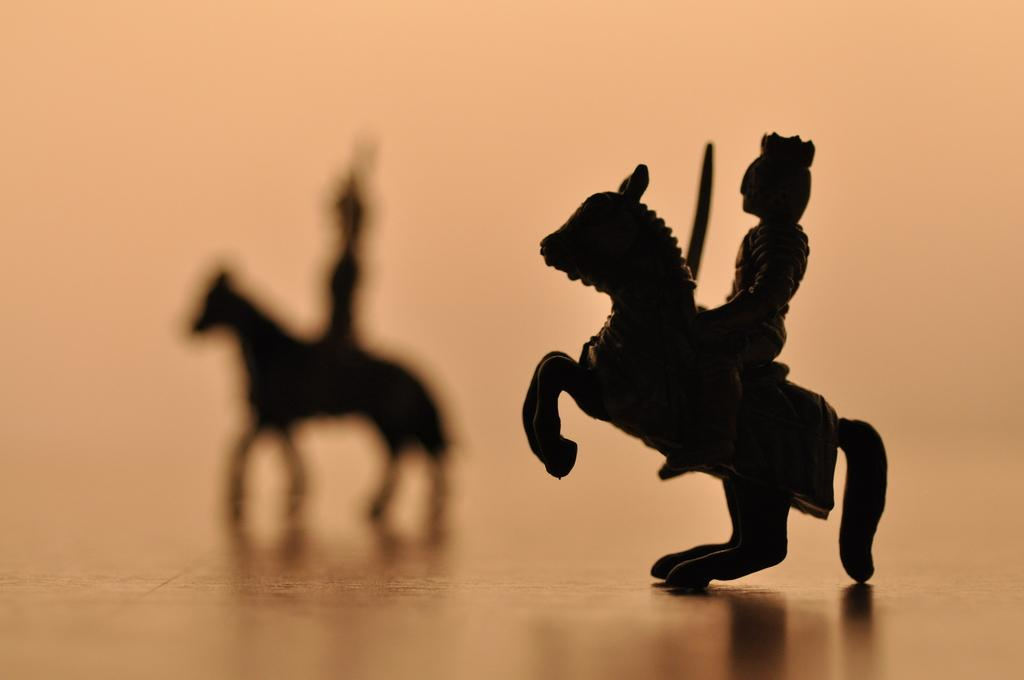What is the main subject of the image? The main subject of the image is a showpiece of a horse. What is the horse depicted as doing in the image? The horse is depicted as jumping in the image. Is there a person on the horse in the image? Yes, there is a person on the horse in the image. What is the person holding in their hands? The person is holding a sword in their hands. What can be seen in the background of the image? There is a shadow in the background of the image. What type of impulse is being used to power the horse in the image? There is no indication in the image that the horse is being powered by any impulse; it is a showpiece of a horse. What type of beam is supporting the horse in the image? The horse is a showpiece and not supported by any beam; it is likely mounted on a base or stand. 